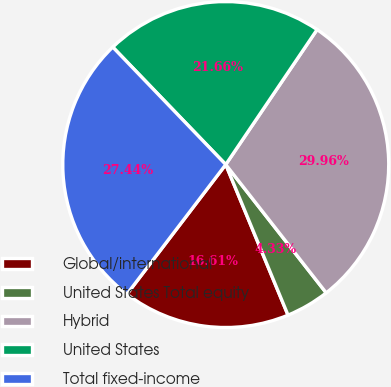Convert chart to OTSL. <chart><loc_0><loc_0><loc_500><loc_500><pie_chart><fcel>Global/international<fcel>United States Total equity<fcel>Hybrid<fcel>United States<fcel>Total fixed-income<nl><fcel>16.61%<fcel>4.33%<fcel>29.96%<fcel>21.66%<fcel>27.44%<nl></chart> 